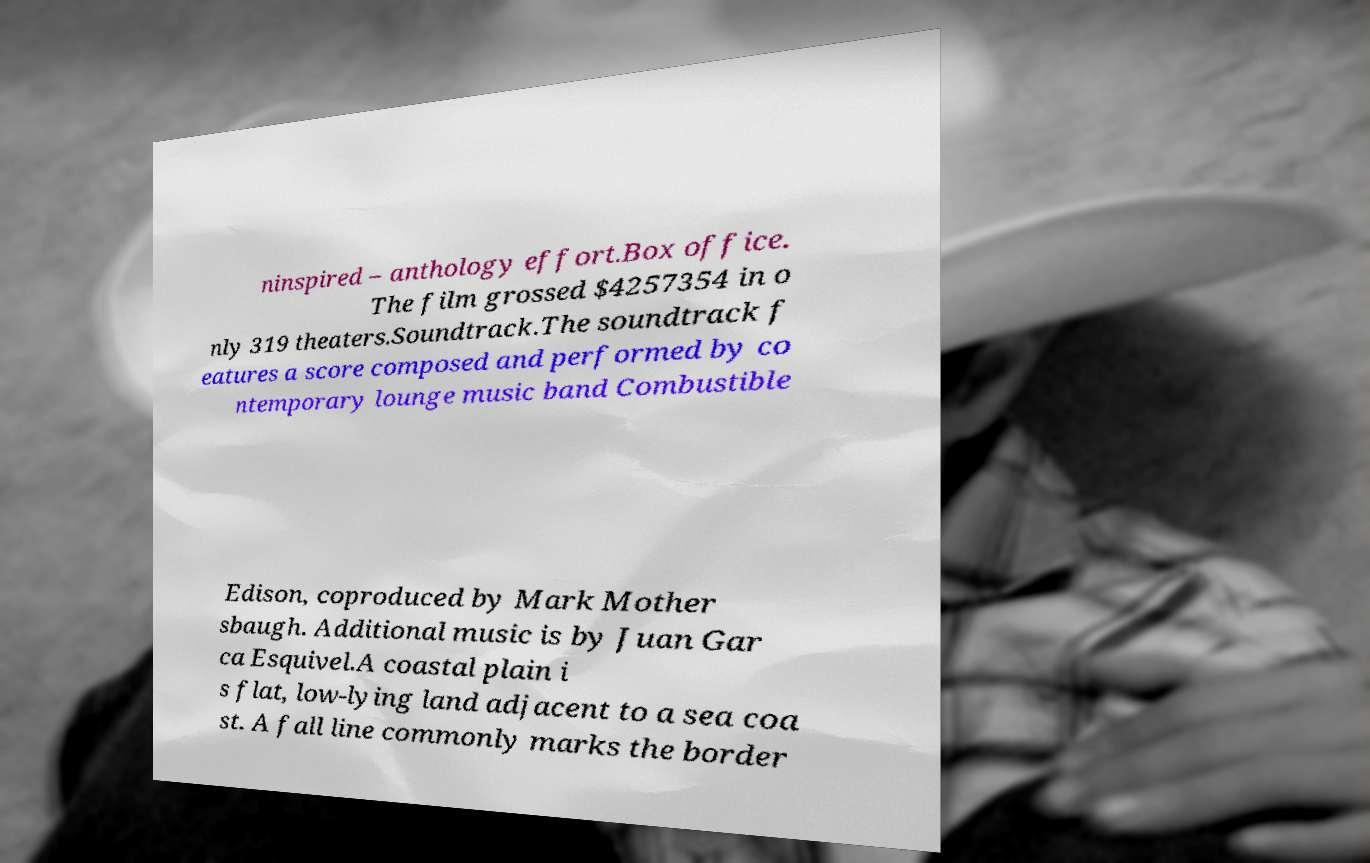Can you read and provide the text displayed in the image?This photo seems to have some interesting text. Can you extract and type it out for me? ninspired – anthology effort.Box office. The film grossed $4257354 in o nly 319 theaters.Soundtrack.The soundtrack f eatures a score composed and performed by co ntemporary lounge music band Combustible Edison, coproduced by Mark Mother sbaugh. Additional music is by Juan Gar ca Esquivel.A coastal plain i s flat, low-lying land adjacent to a sea coa st. A fall line commonly marks the border 